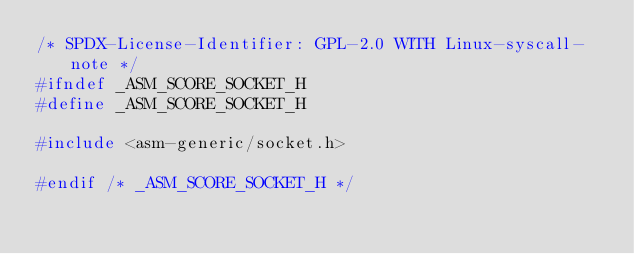Convert code to text. <code><loc_0><loc_0><loc_500><loc_500><_C_>/* SPDX-License-Identifier: GPL-2.0 WITH Linux-syscall-note */
#ifndef _ASM_SCORE_SOCKET_H
#define _ASM_SCORE_SOCKET_H

#include <asm-generic/socket.h>

#endif /* _ASM_SCORE_SOCKET_H */
</code> 